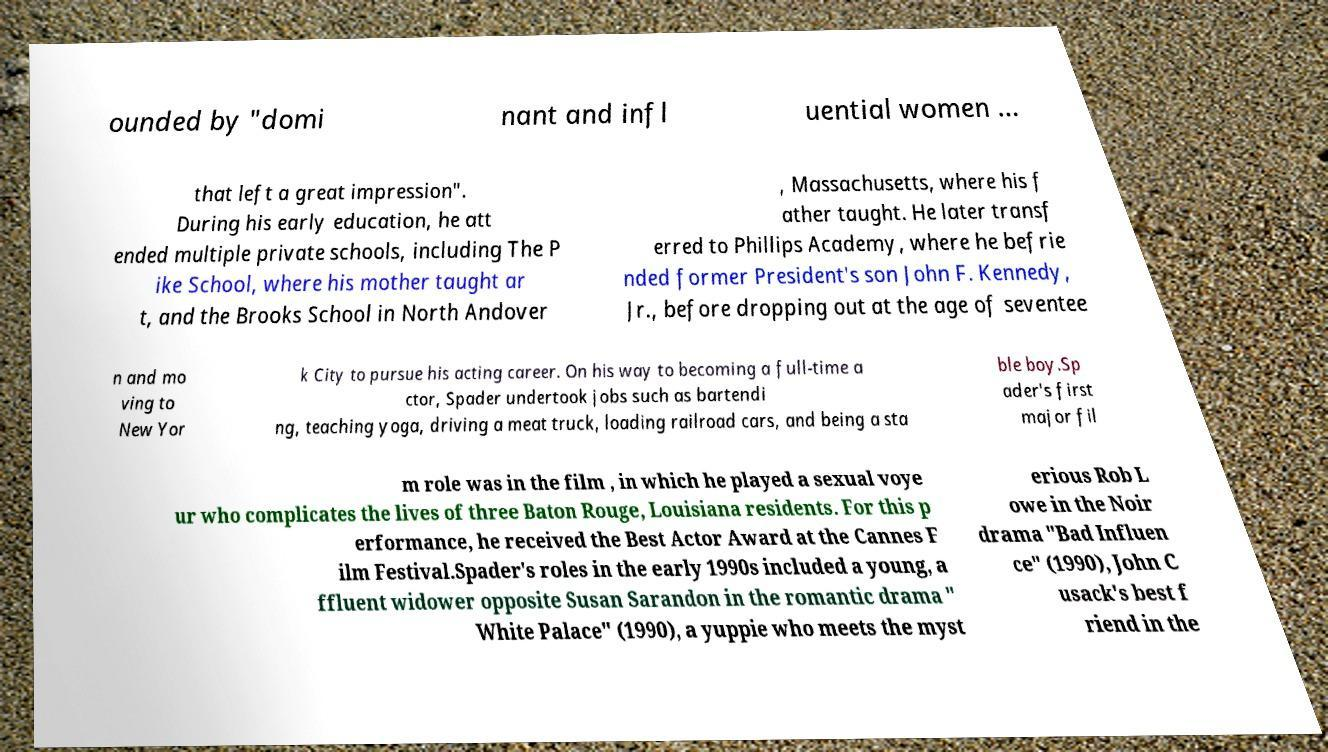Can you accurately transcribe the text from the provided image for me? ounded by "domi nant and infl uential women ... that left a great impression". During his early education, he att ended multiple private schools, including The P ike School, where his mother taught ar t, and the Brooks School in North Andover , Massachusetts, where his f ather taught. He later transf erred to Phillips Academy, where he befrie nded former President's son John F. Kennedy, Jr., before dropping out at the age of seventee n and mo ving to New Yor k City to pursue his acting career. On his way to becoming a full-time a ctor, Spader undertook jobs such as bartendi ng, teaching yoga, driving a meat truck, loading railroad cars, and being a sta ble boy.Sp ader's first major fil m role was in the film , in which he played a sexual voye ur who complicates the lives of three Baton Rouge, Louisiana residents. For this p erformance, he received the Best Actor Award at the Cannes F ilm Festival.Spader's roles in the early 1990s included a young, a ffluent widower opposite Susan Sarandon in the romantic drama " White Palace" (1990), a yuppie who meets the myst erious Rob L owe in the Noir drama "Bad Influen ce" (1990), John C usack's best f riend in the 